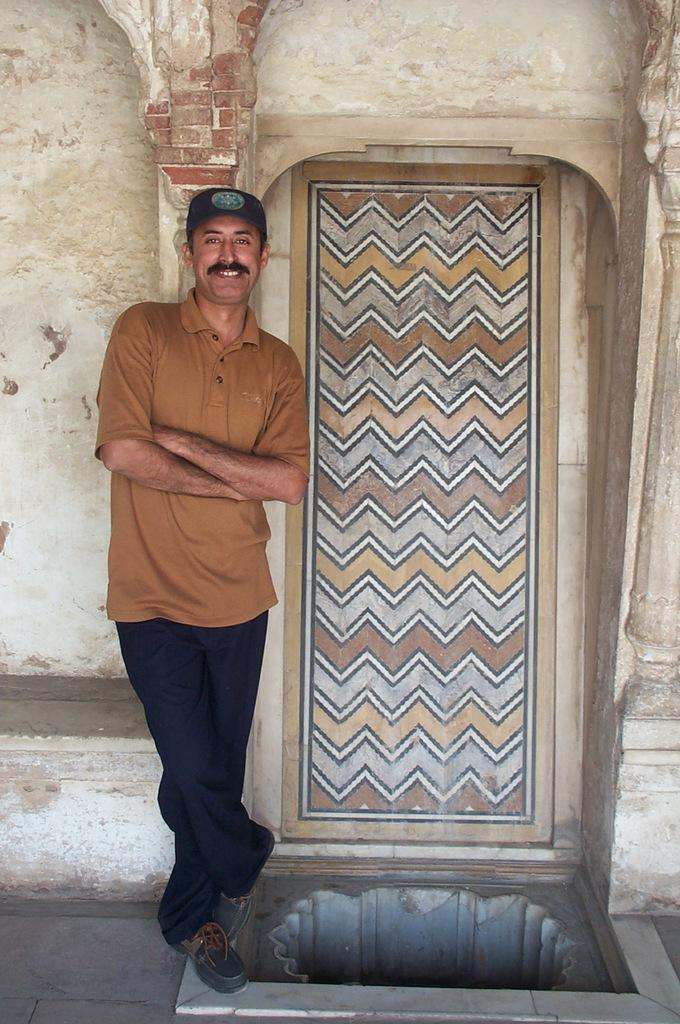What type of structure is in the picture? There is an old building in the picture. Can you describe any specific features of the building? There is a door in the picture. Who or what is present in the picture besides the building? There is a person standing in the picture. What is the person doing in the picture? The person is folding his hands. Can you see any wings on the person in the picture? There are no wings visible on the person in the picture. What type of wristwatch is the person wearing in the image? There is no wristwatch visible on the person in the image. 